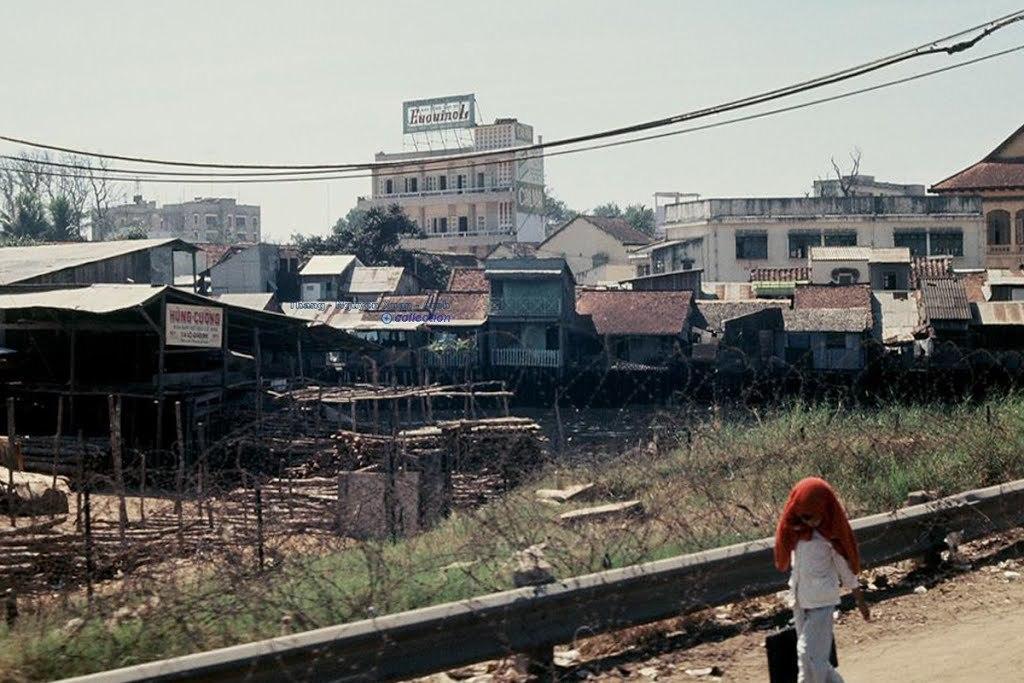Can you describe this image briefly? This is an outside view. On the right bottom of the image I can see a person holding a bag in hand and walking on the road. Beside the road I can see the plants and grass. In the background there are some buildings and trees. On the top of the image I can see the sky. 